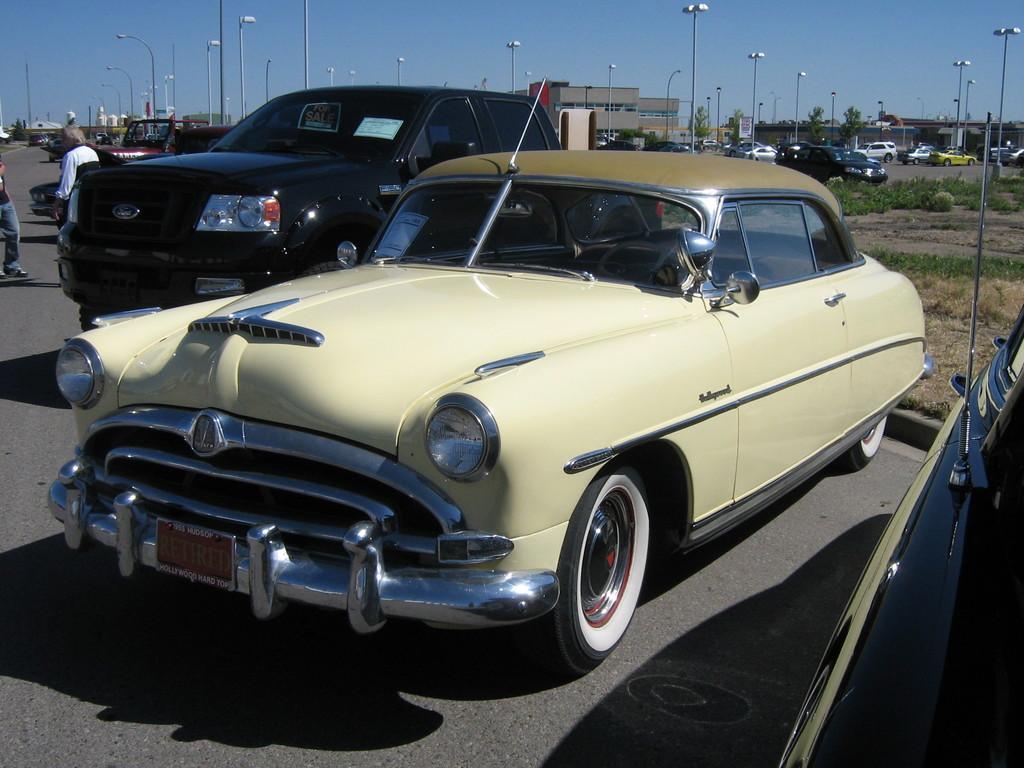Can you describe this image briefly? In this image I can see a road in the front and on it I can see few vehicles. In the background I can see number of poles, number of lights, grass, few more vehicles, few trees, few buildings and the sky. On the left side of this image I can see few people are standing. 